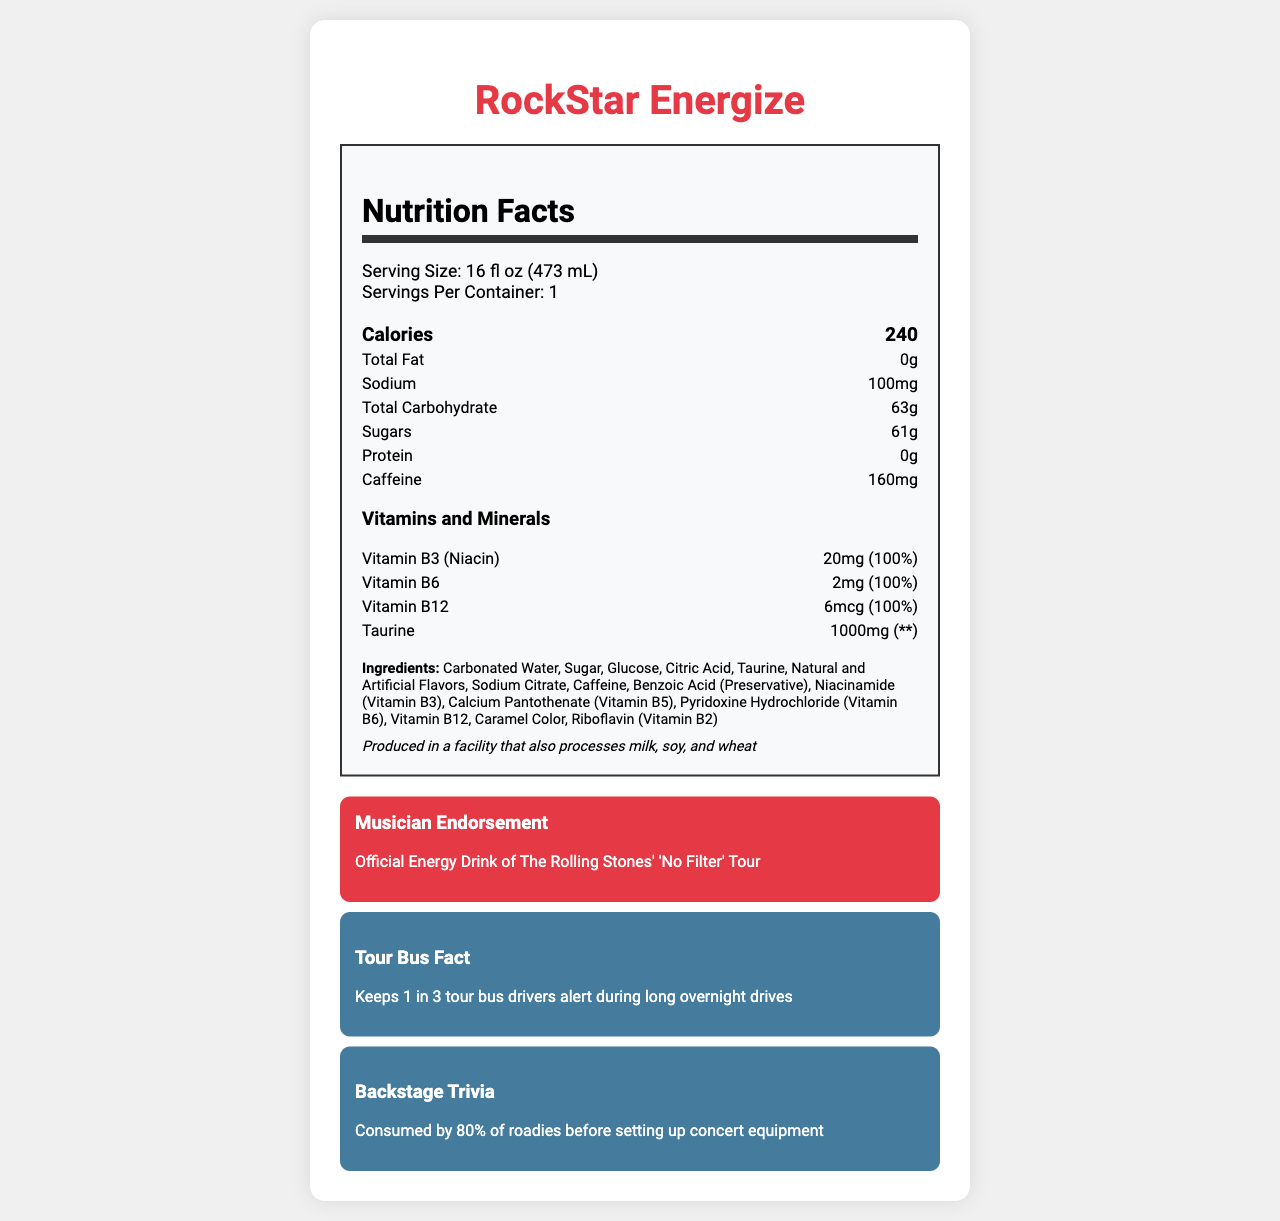What is the serving size of RockStar Energize? The serving size is clearly stated in the "Serving Size" section of the nutrition label as "16 fl oz (473 mL)".
Answer: 16 fl oz (473 mL) How many calories does one serving of RockStar Energize contain? The "Calories" section in the nutrition label specifies that one serving contains 240 calories.
Answer: 240 What is the total carbohydrate content per serving of RockStar Energize? The nutrition label lists "Total Carbohydrate" content per serving as 63g.
Answer: 63g Which vitamins are included in RockStar Energize, and what is their daily value percentage? The nutrition label includes vitamins and their daily value percentages: Vitamin B3 (Niacin) - 100%, Vitamin B6 - 100%, and Vitamin B12 - 100%.
Answer: Vitamin B3 (Niacin) - 100%, Vitamin B6 - 100%, Vitamin B12 - 100% How much caffeine is in one serving of RockStar Energize? The caffeine content is listed as 160mg per serving on the nutrition label.
Answer: 160mg Which ingredient is listed first in the ingredients list of RockStar Energize? The ingredients list shows Carbonated Water as the first ingredient.
Answer: Carbonated Water What is the total sugar content in one serving of RockStar Energize? The nutrition label specifies the "Sugars" content as 61g per serving.
Answer: 61g What is the sodium content per serving of RockStar Energize? The sodium content per serving is listed as 100mg on the nutrition label.
Answer: 100mg Is RockStar Energize produced in a facility that processes allergens? The allergen information indicates that the product is produced in a facility that also processes milk, soy, and wheat.
Answer: Yes Which tour's official energy drink is RockStar Energize? A. U2's 'The Joshua Tree' Tour B. The Rolling Stones' 'No Filter' Tour C. Coldplay's 'A Head Full of Dreams' Tour The musician endorsement mentions that RockStar Energize is the official energy drink of The Rolling Stones' 'No Filter' Tour.
Answer: B What percentage of roadies consume RockStar Energize before setting up concert equipment? A. 50% B. 80% C. 90% The backstage trivia section states that 80% of roadies consume RockStar Energize before setting up concert equipment.
Answer: B How many servings are there in one container of RockStar Energize? The nutrition label clearly states that there is 1 serving per container.
Answer: 1 What is the main idea of the document? The document includes detailed nutritional facts, ingredients, allergen information, endorsements by The Rolling Stones, and trivia about its consumption by musicians and roadies.
Answer: The document provides the nutritional information and highlights endorsements of RockStar Energize, a popular energy drink. What is the taurine content in one serving of RockStar Energize? The vitamins and minerals section lists taurine content as 1000mg per serving.
Answer: 1000mg What is the daily value percentage for taurine mentioned in the nutrition label? The nutrition label shows '**' for taurine's daily value, indicating that it is not established.
Answer: ** How much protein is in one serving of RockStar Energize? The nutrition label indicates that there is no protein (0g) in one serving.
Answer: 0g What is the vitamin B12 content in RockStar Energize? The vitamins and minerals section lists vitamin B12 content as 6mcg.
Answer: 6mcg Did The Rolling Stones endorse RockStar Energize during their 'No Filter' tour? The musician endorsement section states that RockStar Energize is the official energy drink of The Rolling Stones’ 'No Filter' Tour.
Answer: Yes Who manufactures RockStar Energize? The document states that RockStar Energy Company is the manufacturer of RockStar Energize.
Answer: RockStar Energy Company How many calories are contributed by the total sugar content in RockStar Energize? The nutrition label does not provide enough information to calculate the calories contributed specifically by the sugar content alone.
Answer: Cannot be determined How does RockStar Energize help touring musicians? The document details the nutritional benefits and endorsements, indicating its role in providing energy, especially on long tour drives and before equipment setups.
Answer: It provides energy through its high sugar and caffeine content, along with essential vitamins, and is endorsed and consumed by musicians and roadies for energy and alertness. What color is used for the title "RockStar Energize"? The document uses a red color for the title "RockStar Energize".
Answer: Red Is RockStar Energize suitable for people with milk allergies? The allergen information indicates that it is produced in a facility that also processes milk.
Answer: No 